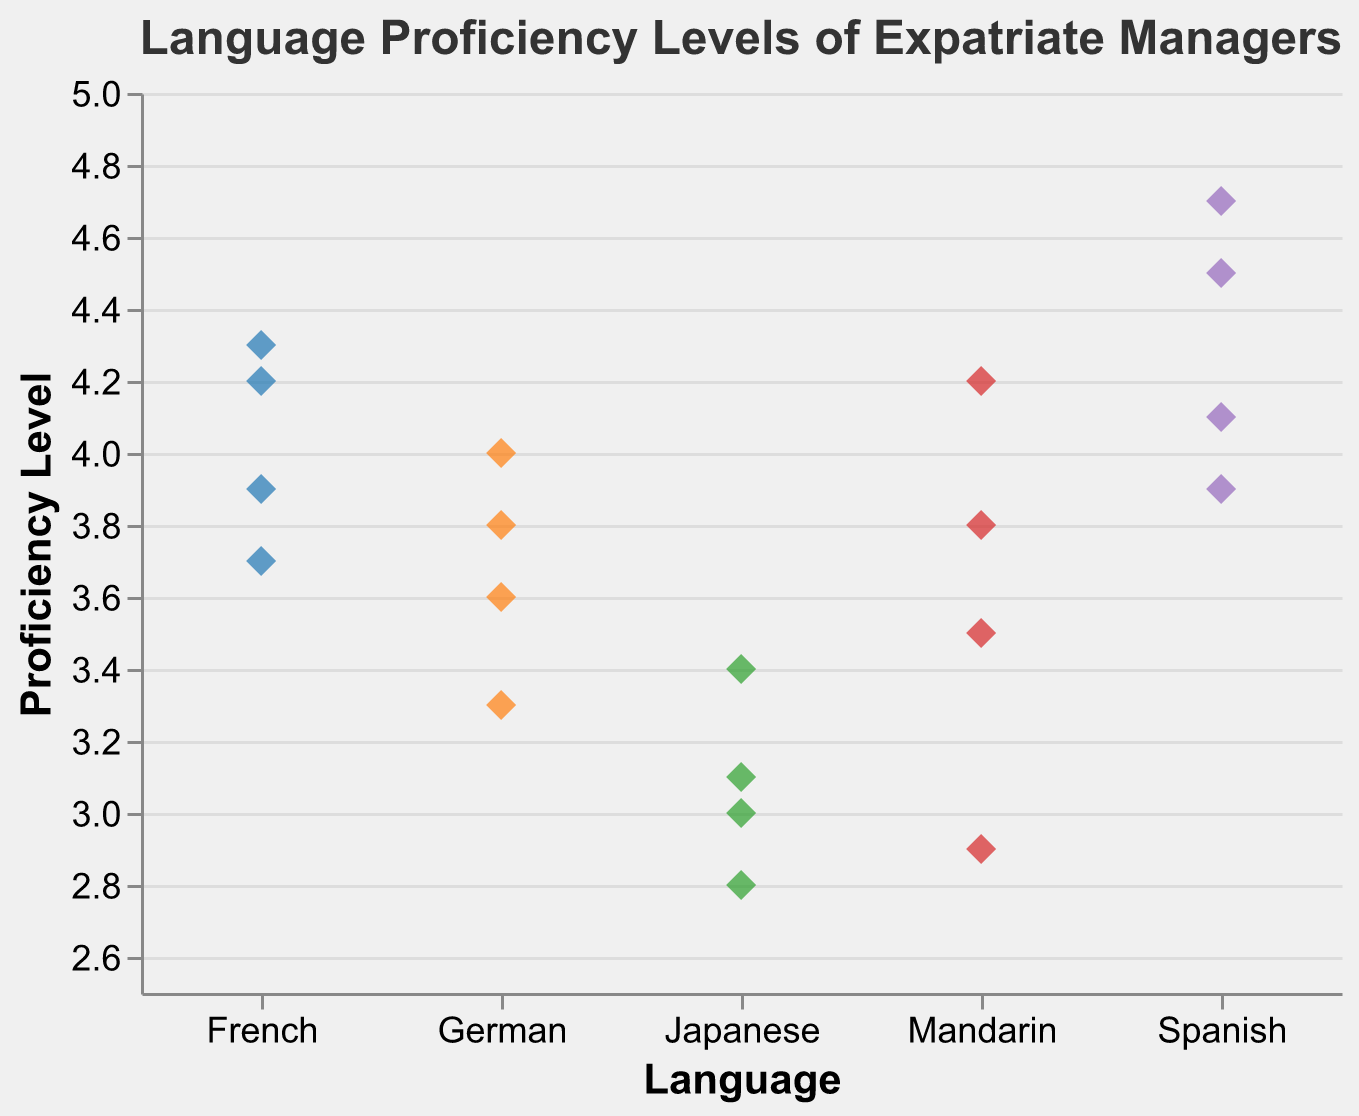What's the title of the plot? The title of the plot is displayed at the top and reads "Language Proficiency Levels of Expatriate Managers."
Answer: Language Proficiency Levels of Expatriate Managers What is the range of the proficiency levels observed for the Japanese language? The proficiency levels of the Japanese language can be seen along the y-axis for the data points corresponding to Japanese. They range from 2.8 to 3.4.
Answer: 2.8 to 3.4 Which language has the highest individual proficiency level, and what is that level? The highest individual proficiency level can be identified by looking at the highest point across all languages on the y-axis. Spanish has the highest individual proficiency level at 4.7.
Answer: Spanish, 4.7 How many data points are there for the French language? By counting the number of points for French on the x-axis, you can see that there are four data points.
Answer: 4 What is the average proficiency level for Spanish-speaking managers? Sum the proficiency levels for Spanish and divide by the number of Spanish data points: (4.7 + 4.1 + 3.9 + 4.5) / 4 = 17.2 / 4 = 4.3.
Answer: 4.3 Which language shows the greatest variability in proficiency levels? By observing the spread of data points vertically for each language, Mandarin shows the greatest variability with proficiency levels ranging from 2.9 to 4.2.
Answer: Mandarin Are there any languages with identical proficiency levels? If so, which levels and languages are they? By inspecting the y-axis values across different languages, French and Mandarin both have a data point at 4.2.
Answer: French, Mandarin (4.2) What is the median proficiency level for managers speaking German? Arrange the German data points in ascending order: 3.3, 3.6, 3.8, 4.0. The median is the average of the second and third values: (3.6 + 3.8) / 2 = 3.7.
Answer: 3.7 Which language has the closest average proficiency level to 4.0? Calculate the averages and compare them to 4.0: 
Mandarin: (4.2 + 3.8 + 2.9 + 3.5)/4 = 3.6, 
Spanish: 4.3 (previously calculated), 
German: (3.6 + 4.0 + 3.3 + 3.8)/4 = 3.675, 
French: (4.3 + 3.7 + 4.2 + 3.9)/4 = 4.025. French is closest.
Answer: French Within the proficiency range shown, how many languages have maximum levels above 4.0? Reading from the plot, Spanish, French, and Mandarin have maximum levels above 4.0.
Answer: 3 